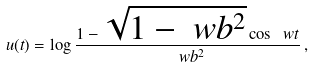<formula> <loc_0><loc_0><loc_500><loc_500>u ( t ) = \log \frac { 1 - \sqrt { 1 - \ w b ^ { 2 } } \cos \ w t } { \ w b ^ { 2 } } \, ,</formula> 